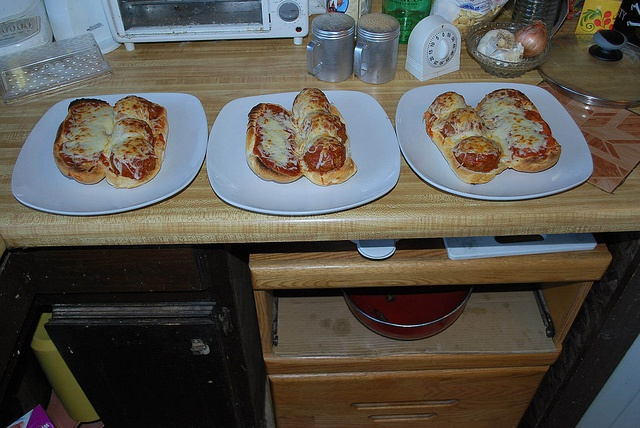Describe the objects in this image and their specific colors. I can see sandwich in gray, maroon, olive, and darkgray tones, sandwich in gray, maroon, and darkgray tones, sandwich in gray, darkgray, maroon, and tan tones, microwave in gray, lightblue, blue, and black tones, and hot dog in gray, darkgray, maroon, and tan tones in this image. 